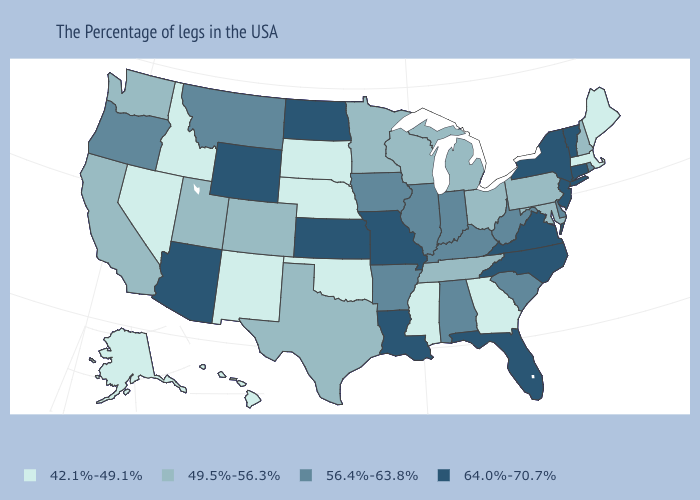Which states have the lowest value in the West?
Give a very brief answer. New Mexico, Idaho, Nevada, Alaska, Hawaii. Does Alaska have a higher value than New Mexico?
Concise answer only. No. Among the states that border Oklahoma , which have the highest value?
Write a very short answer. Missouri, Kansas. What is the value of Rhode Island?
Answer briefly. 56.4%-63.8%. What is the value of West Virginia?
Give a very brief answer. 56.4%-63.8%. Which states have the lowest value in the South?
Be succinct. Georgia, Mississippi, Oklahoma. What is the highest value in states that border Maryland?
Give a very brief answer. 64.0%-70.7%. Is the legend a continuous bar?
Short answer required. No. Does Louisiana have the highest value in the South?
Be succinct. Yes. Name the states that have a value in the range 56.4%-63.8%?
Give a very brief answer. Rhode Island, Delaware, South Carolina, West Virginia, Kentucky, Indiana, Alabama, Illinois, Arkansas, Iowa, Montana, Oregon. Name the states that have a value in the range 49.5%-56.3%?
Short answer required. New Hampshire, Maryland, Pennsylvania, Ohio, Michigan, Tennessee, Wisconsin, Minnesota, Texas, Colorado, Utah, California, Washington. What is the lowest value in the West?
Concise answer only. 42.1%-49.1%. Does the map have missing data?
Be succinct. No. Among the states that border Texas , does Arkansas have the lowest value?
Write a very short answer. No. 